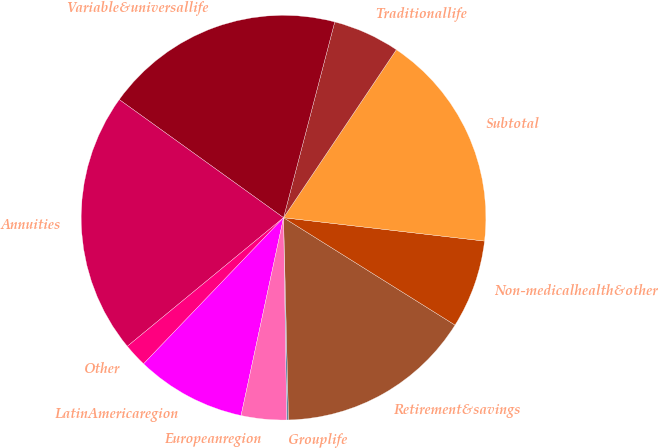Convert chart. <chart><loc_0><loc_0><loc_500><loc_500><pie_chart><fcel>Grouplife<fcel>Retirement&savings<fcel>Non-medicalhealth&other<fcel>Subtotal<fcel>Traditionallife<fcel>Variable&universallife<fcel>Annuities<fcel>Other<fcel>LatinAmericaregion<fcel>Europeanregion<nl><fcel>0.15%<fcel>15.7%<fcel>7.06%<fcel>17.43%<fcel>5.34%<fcel>19.15%<fcel>20.88%<fcel>1.88%<fcel>8.79%<fcel>3.61%<nl></chart> 